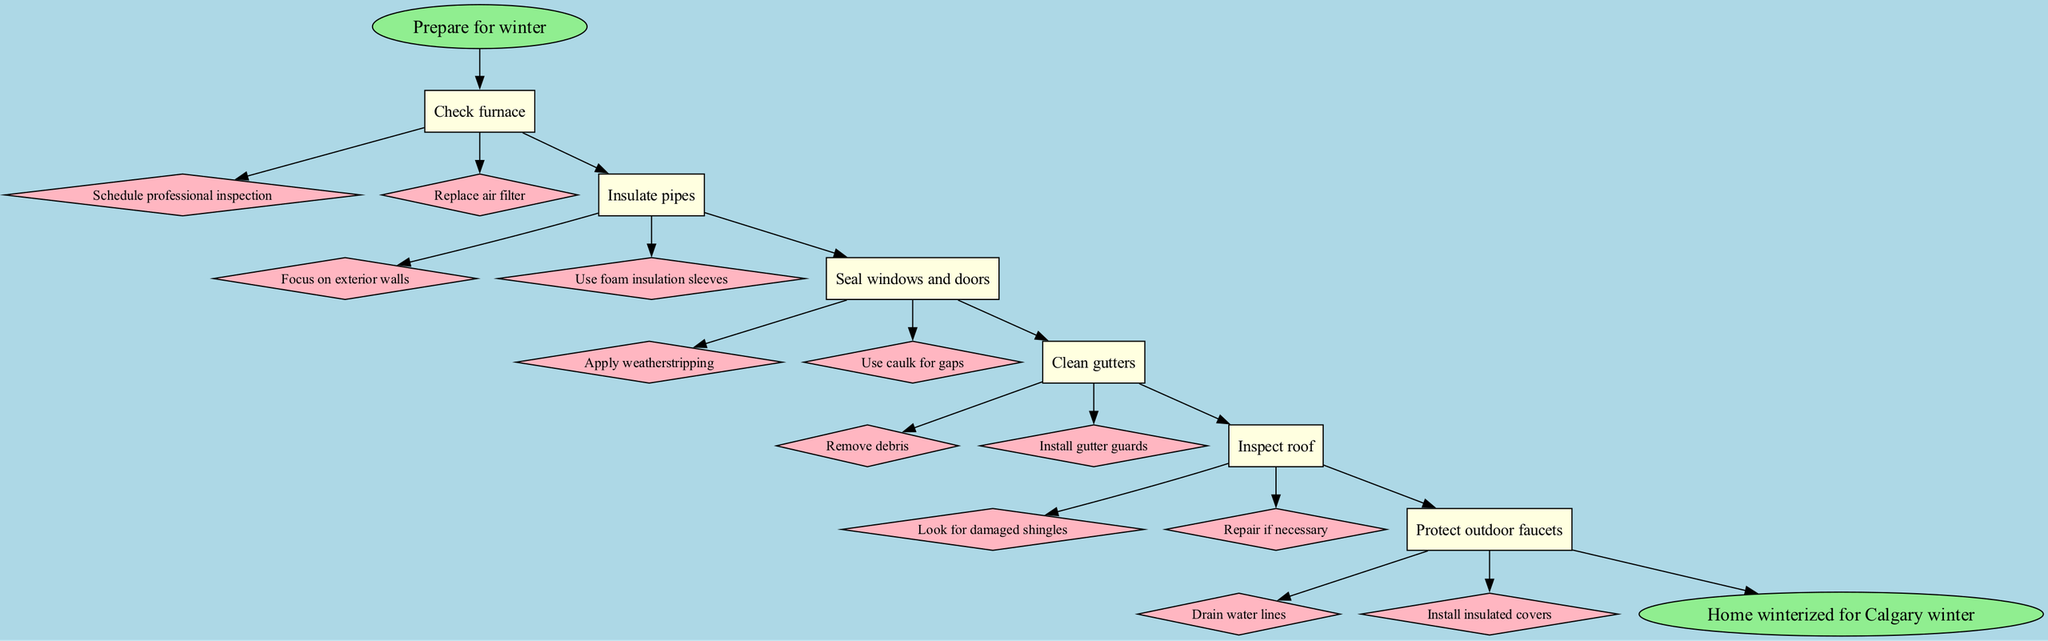What is the first step in winterizing your home? The diagram indicates that the first step after "Prepare for winter" is "Check furnace." Therefore, we can find this by looking at the first node after the starting point.
Answer: Check furnace How many substeps are listed under "Seal windows and doors"? To find the number of substeps, we look at the section related to "Seal windows and doors," which lists two substeps: "Apply weatherstripping" and "Use caulk for gaps." Counting these provides the answer.
Answer: 2 What node follows "Inspect roof" in the diagram? We can find the node that follows "Inspect roof" by looking at the edges that connect the nodes. The next node after "Inspect roof" is "Protect outdoor faucets."
Answer: Protect outdoor faucets What is the final step indicated in the flowchart? The last node connected in the flowchart is labeled as "Home winterized for Calgary winter." This is identified as the endpoint of the process.
Answer: Home winterized for Calgary winter Which step contains the most substeps in the diagram? To identify the step with the most substeps, we need to count the number of substeps for each step. The steps for "Check furnace," "Insulate pipes," "Seal windows and doors," "Clean gutters," "Inspect roof," and "Protect outdoor faucets" each contain varying numbers of substeps. It can be observed that four steps have the same number of substeps, but "Check furnace" has two substeps while the others have two or less.
Answer: Check furnace What color is used for the substeps nodes in this flowchart? The diagram specifies that substeps are represented by diamond-shaped nodes filled with light pink color, which we can see from the visual properties assigned to those nodes.
Answer: Light pink 